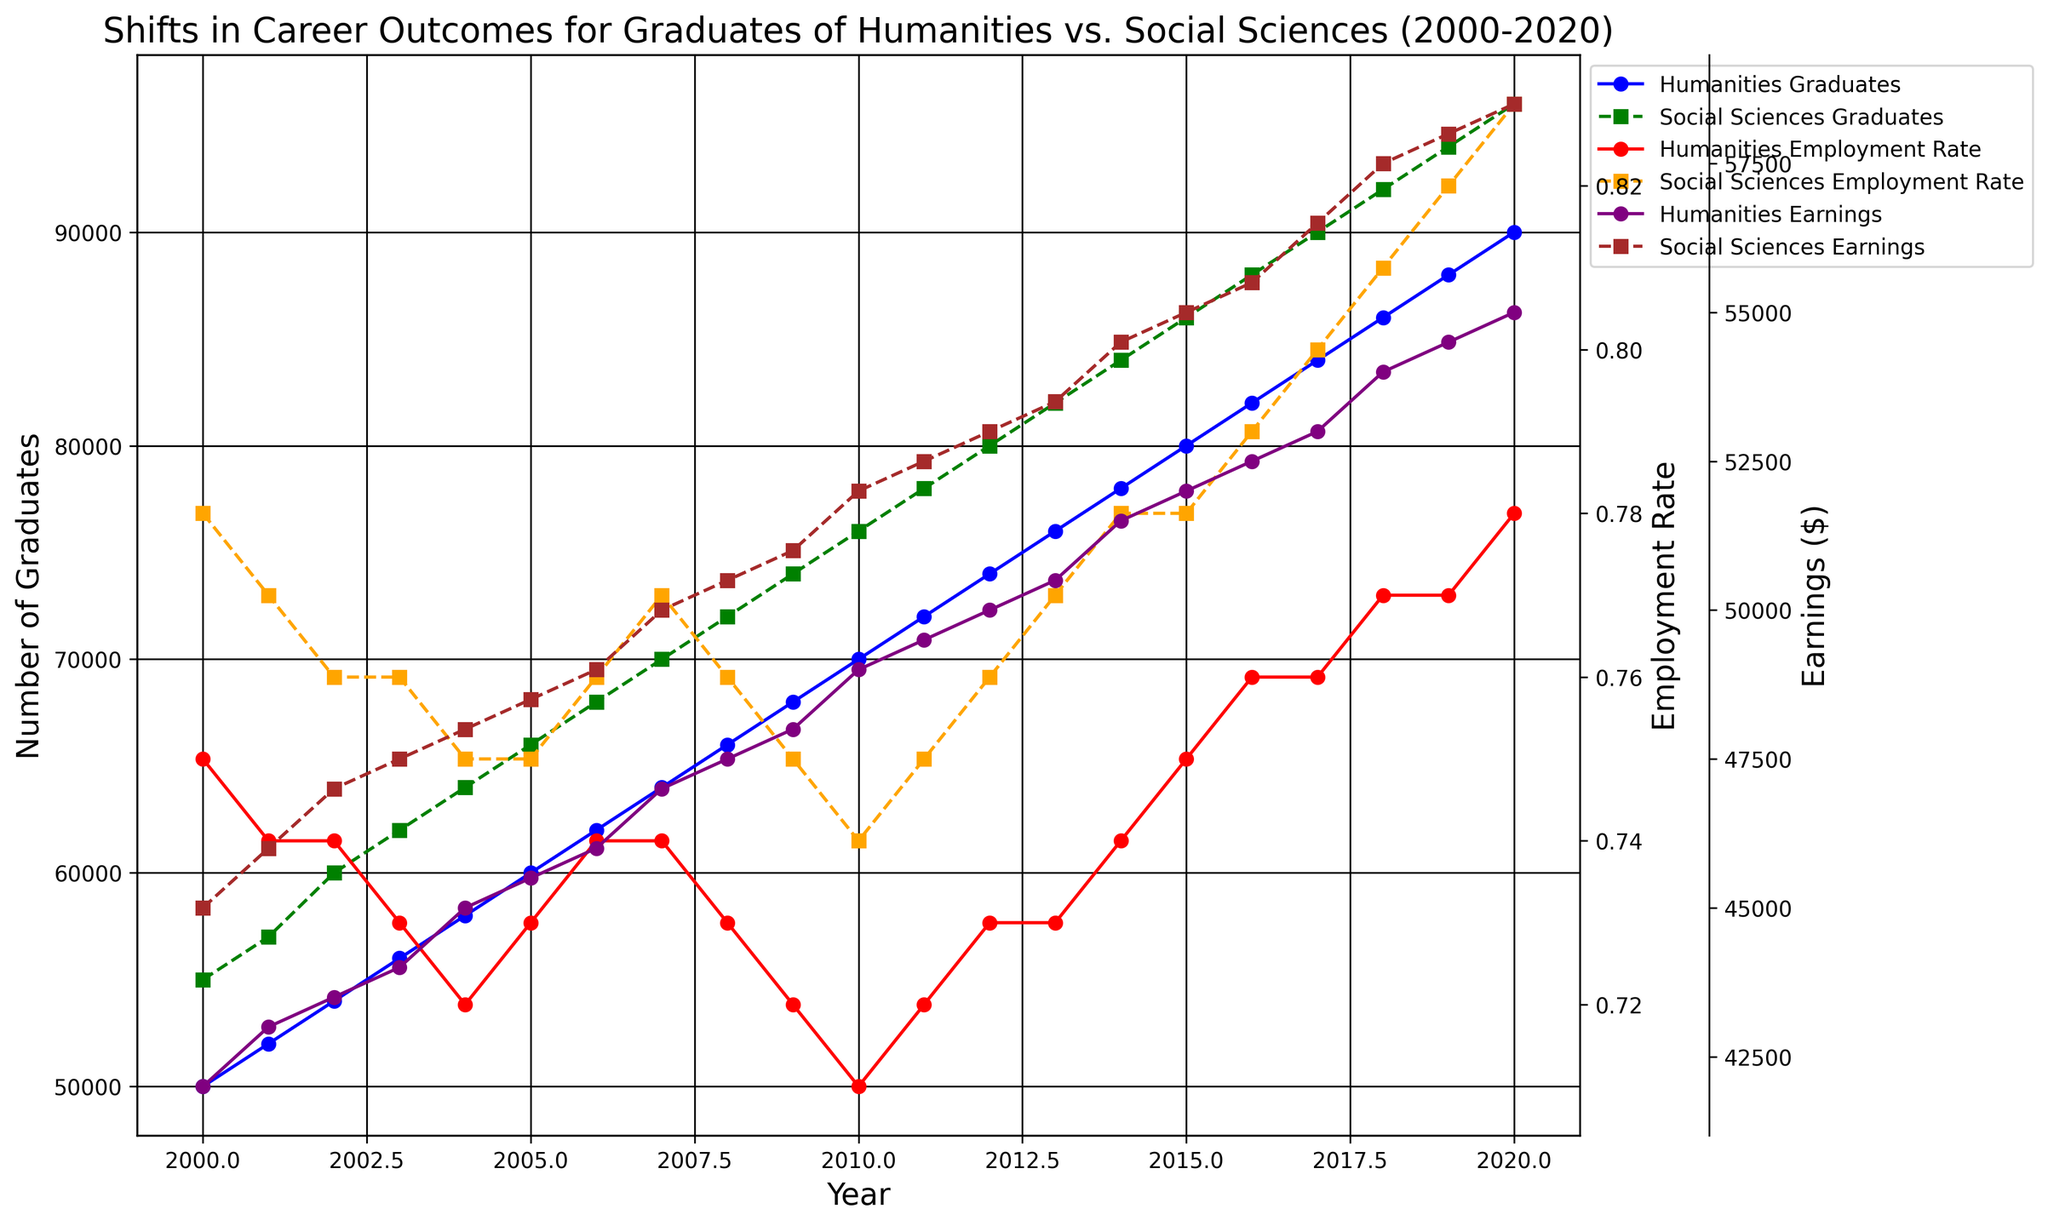When did the number of Social Sciences graduates first reach 60,000? The Social Sciences Graduates line reaches 60,000 in the year 2002 as the plot shows a value of 60,000 at that point.
Answer: 2002 What is the difference in employment rates between Humanities and Social Sciences graduates in 2010? In 2010, the Humanities Employment Rate is 0.71, and the Social Sciences Employment Rate is 0.74. The difference is calculated as 0.74 - 0.71.
Answer: 0.03 How did the earnings trend for Humanities graduates differ from that for Social Sciences graduates between 2005 and 2010? From 2005 to 2010, the Humanities Earnings increased steadily from 45500 to 49000 while the Social Sciences Earnings also increased from 48500 to 52000. Both trends show consistent upward trajectories, but Social Sciences earnings had a higher initial value and overall increase.
Answer: Steady increase for both Which year corresponds to the highest employment rate among Humanities graduates, and what is the rate? The humanitarian employment rate reaches its highest point in the year 2020, as indicated by the red line peaking at 0.78 during this period.
Answer: 2020, 0.78 By how much did the earnings of Social Sciences graduates increase from 2000 to 2020? In 2000, Social Sciences Earnings were 45000 and they increased to 58500 in 2020. The difference is calculated as 58500 - 45000.
Answer: 13500 In which year did the number of Humanities graduates surpass 80,000? The Humanities Graduates line surpasses the 80,000 mark in the year 2016, as observed from the graph where the blue line crosses above 80,000.
Answer: 2016 How did the employment rate for Social Sciences graduates change from 2016 to 2020? The employment rate for Social Sciences graduates increased from 0.79 in 2016 to 0.83 in 2020, according to the orange line showing a rise during these years.
Answer: Increased by 0.04 What visual trend can you observe about the earnings of graduates from both fields? Both the purple and brown lines representing the earnings of Humanities and Social Sciences graduates, respectively, show a consistent upward trend over the years.
Answer: Upward trend Comparing the number of graduates in 2010, which field had more graduates and by how much? In 2010, Humanities Graduates numbered 70000, while Social Sciences Graduates numbered 76000. The difference is calculated as 76000 - 70000.
Answer: Social Sciences, 6000 What was the employment rate for Humanities graduates in 2005, and did it increase or decrease by 2010? The employment rate for Humanities graduates was 0.73 in 2005, and by 2010, it had decreased to 0.71 as shown on the red line in the graph.
Answer: 0.73, decreased to 0.71 